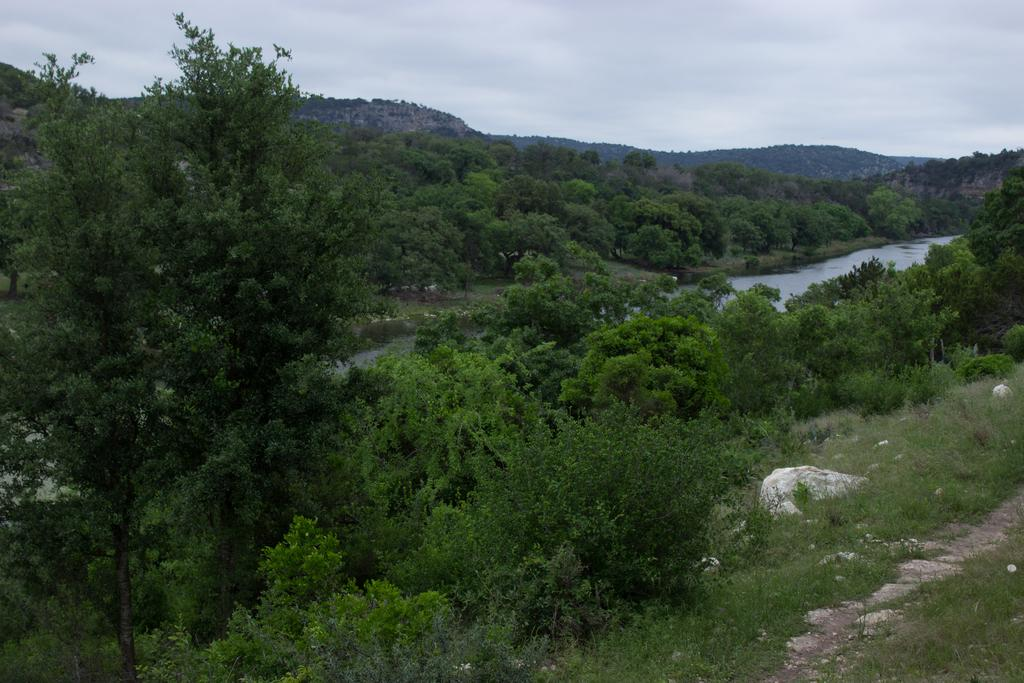Where was the image taken? The image was clicked outside. What can be seen in the foreground of the image? There is green grass, plants, trees, and a water body in the foreground of the image. What is visible in the background of the image? The sky and hills are visible in the background of the image. What type of bed is visible in the image? There is no bed present in the image; it was taken outside with a focus on natural elements. 